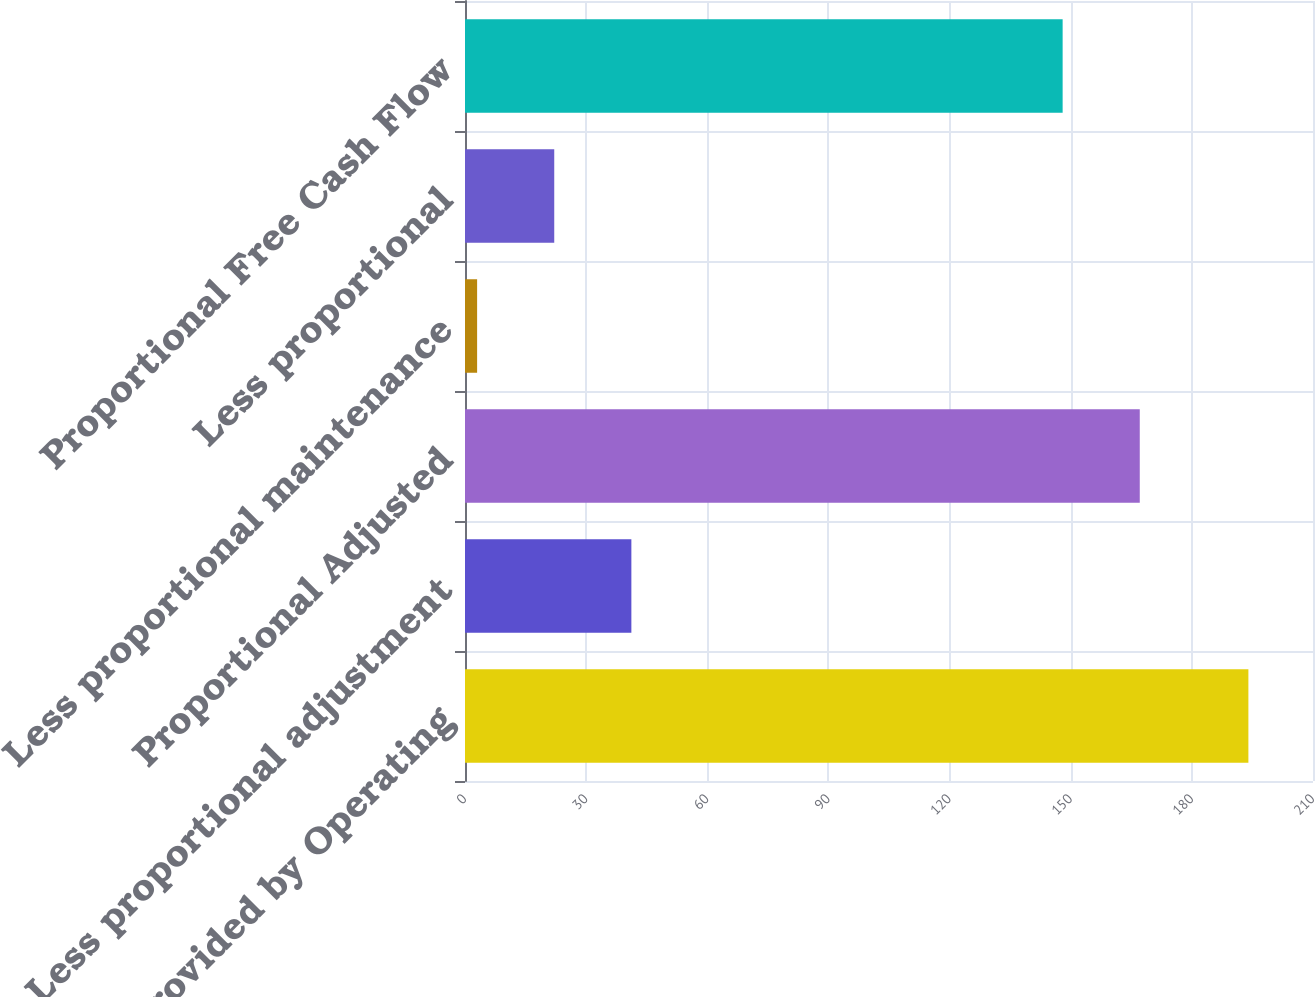<chart> <loc_0><loc_0><loc_500><loc_500><bar_chart><fcel>Net Cash Provided by Operating<fcel>Less proportional adjustment<fcel>Proportional Adjusted<fcel>Less proportional maintenance<fcel>Less proportional<fcel>Proportional Free Cash Flow<nl><fcel>194<fcel>41.2<fcel>167.1<fcel>3<fcel>22.1<fcel>148<nl></chart> 